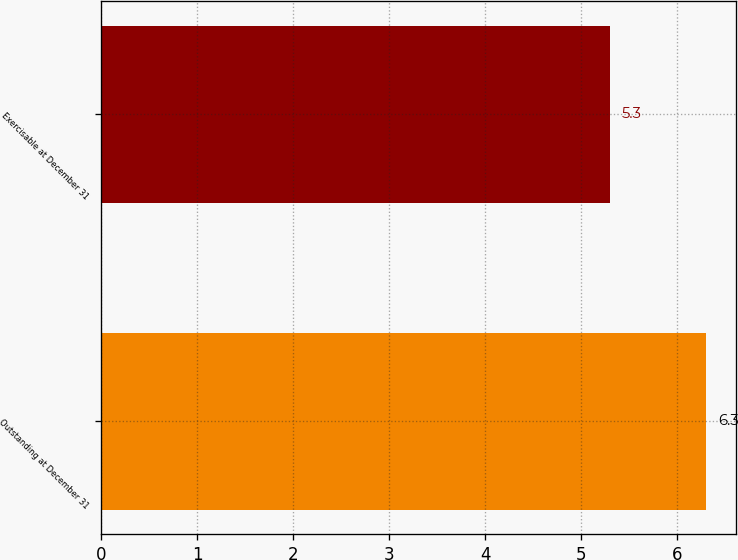Convert chart. <chart><loc_0><loc_0><loc_500><loc_500><bar_chart><fcel>Outstanding at December 31<fcel>Exercisable at December 31<nl><fcel>6.3<fcel>5.3<nl></chart> 